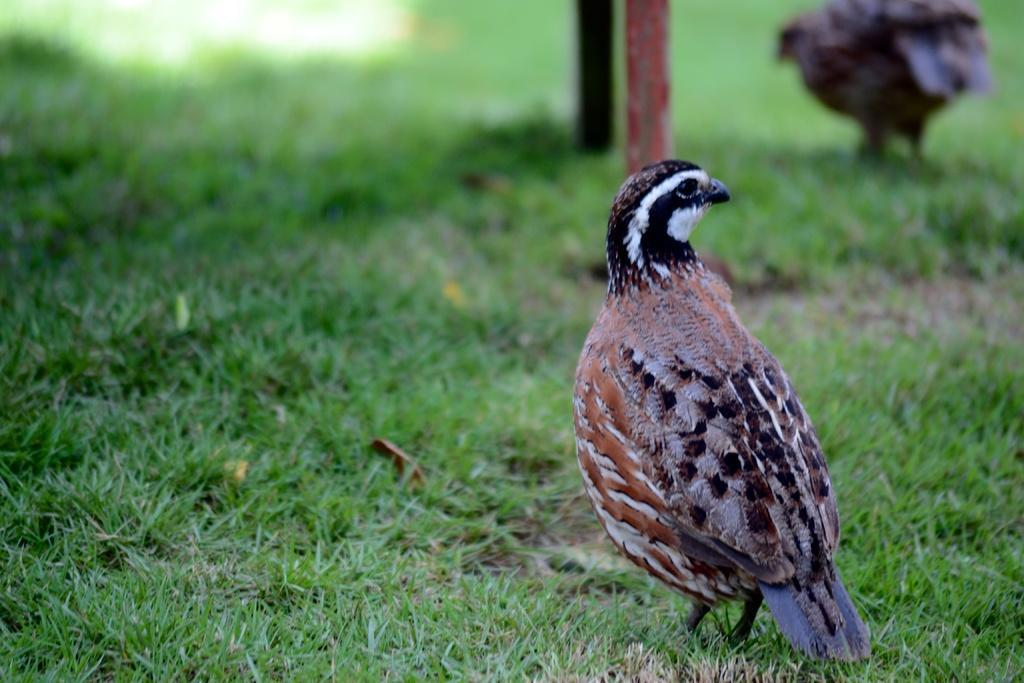Describe this image in one or two sentences. In this picture there is a partridge bird who is standing on the grass. At the top I can see the poles. Beside that I can see another bird. 